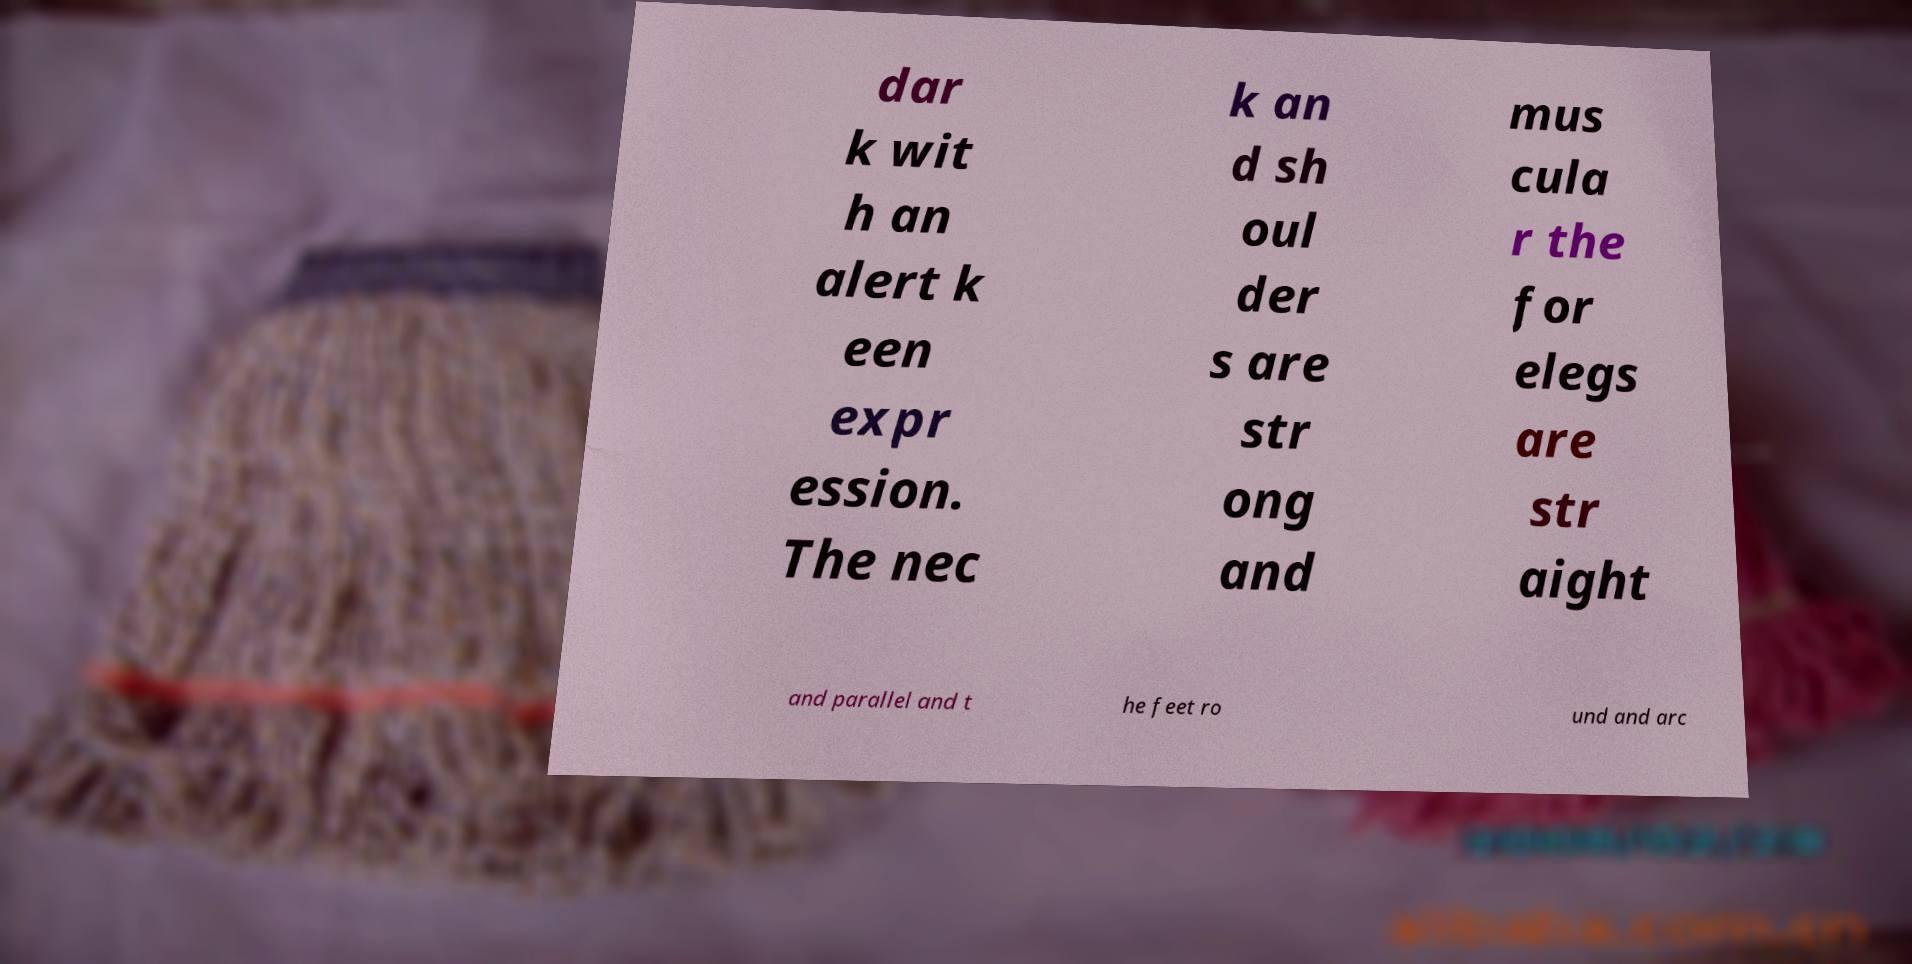Can you accurately transcribe the text from the provided image for me? dar k wit h an alert k een expr ession. The nec k an d sh oul der s are str ong and mus cula r the for elegs are str aight and parallel and t he feet ro und and arc 